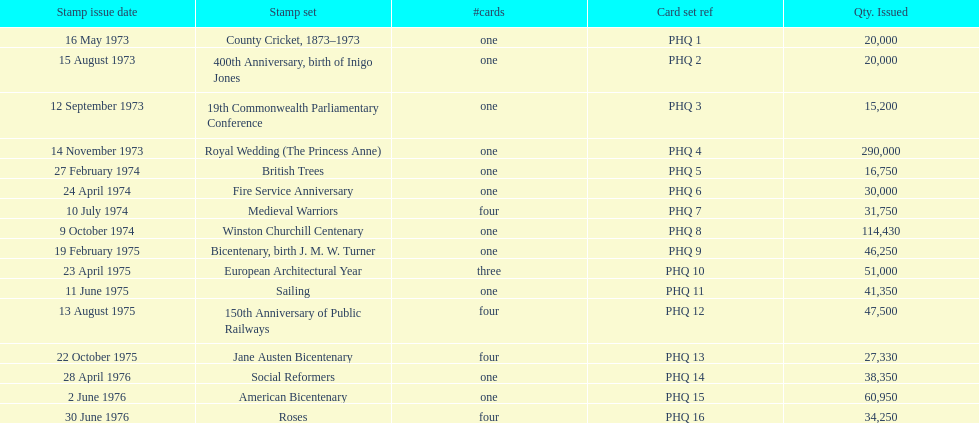Which card was issued most? Royal Wedding (The Princess Anne). 